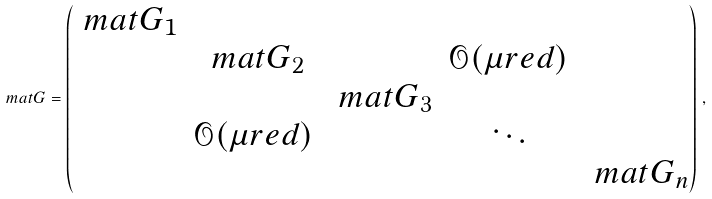Convert formula to latex. <formula><loc_0><loc_0><loc_500><loc_500>\ m a t G = \begin{pmatrix} \ m a t G _ { 1 } & & & & \\ & \ m a t G _ { 2 } & & \mathcal { O } ( \mu r e d ) & \\ & & \ m a t G _ { 3 } & & \\ & \mathcal { O } ( \mu r e d ) & & \ddots & \\ & & & & \ m a t G _ { n } \end{pmatrix} \, ,</formula> 